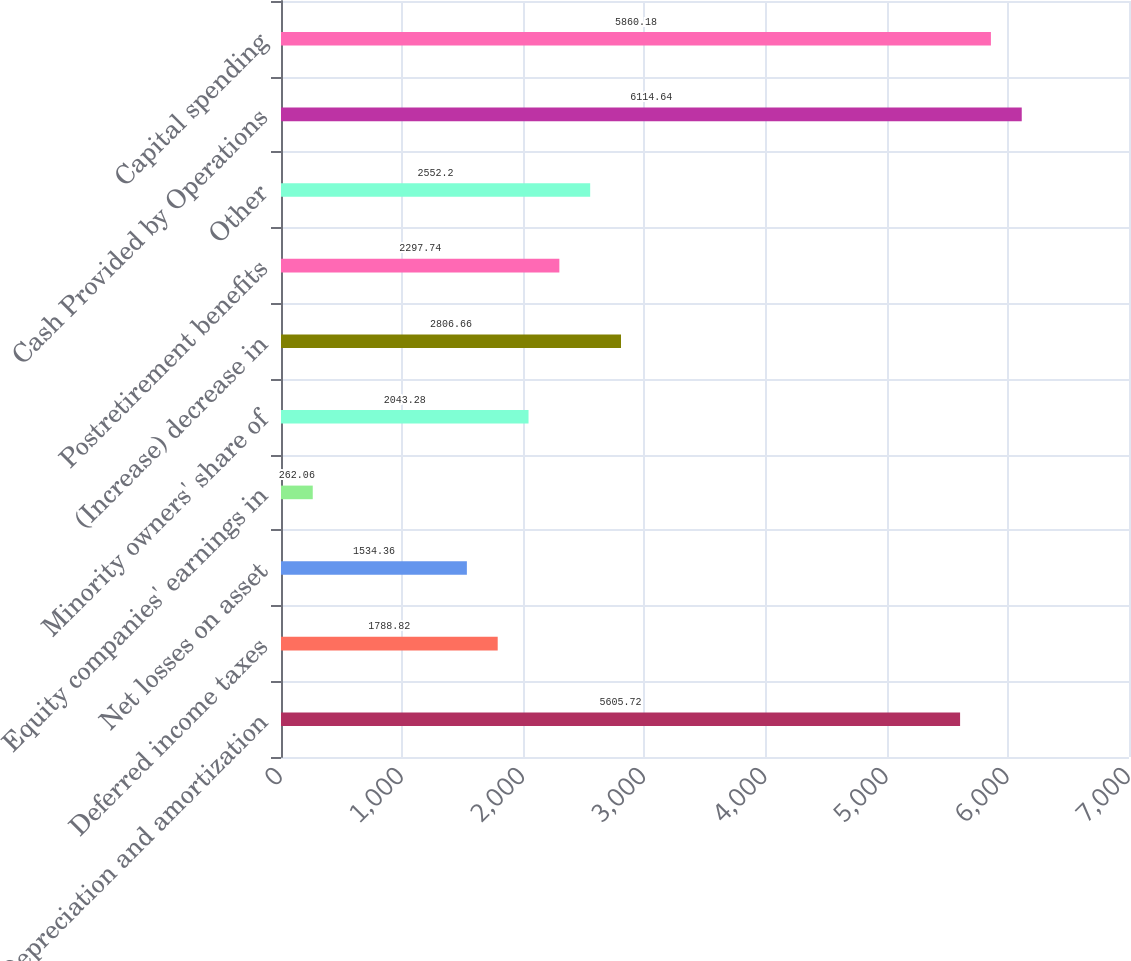Convert chart to OTSL. <chart><loc_0><loc_0><loc_500><loc_500><bar_chart><fcel>Depreciation and amortization<fcel>Deferred income taxes<fcel>Net losses on asset<fcel>Equity companies' earnings in<fcel>Minority owners' share of<fcel>(Increase) decrease in<fcel>Postretirement benefits<fcel>Other<fcel>Cash Provided by Operations<fcel>Capital spending<nl><fcel>5605.72<fcel>1788.82<fcel>1534.36<fcel>262.06<fcel>2043.28<fcel>2806.66<fcel>2297.74<fcel>2552.2<fcel>6114.64<fcel>5860.18<nl></chart> 